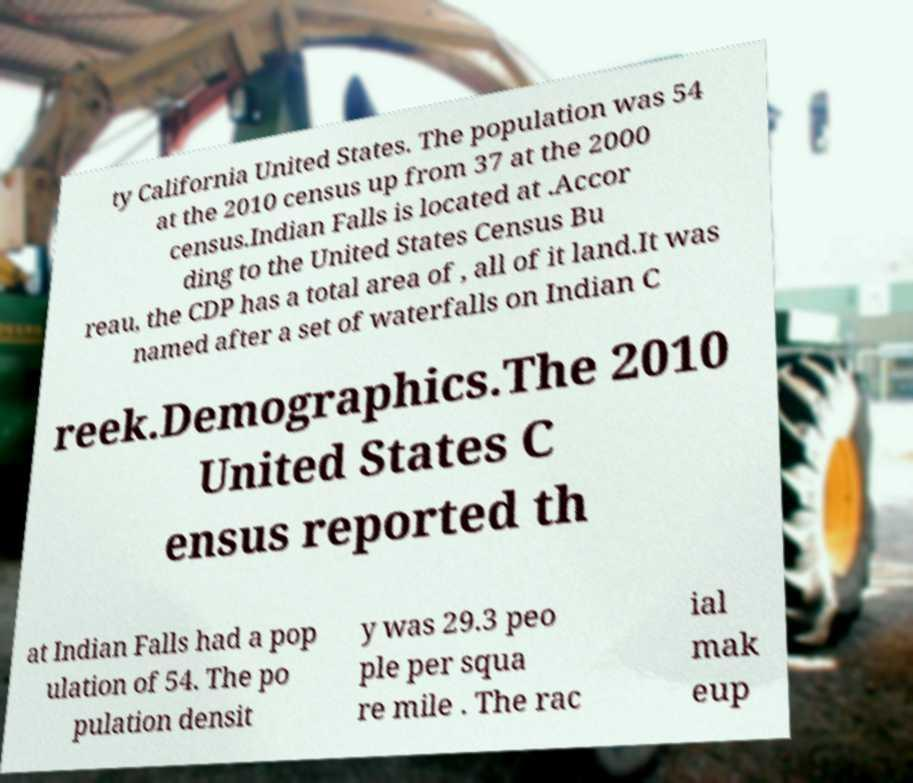I need the written content from this picture converted into text. Can you do that? ty California United States. The population was 54 at the 2010 census up from 37 at the 2000 census.Indian Falls is located at .Accor ding to the United States Census Bu reau, the CDP has a total area of , all of it land.It was named after a set of waterfalls on Indian C reek.Demographics.The 2010 United States C ensus reported th at Indian Falls had a pop ulation of 54. The po pulation densit y was 29.3 peo ple per squa re mile . The rac ial mak eup 